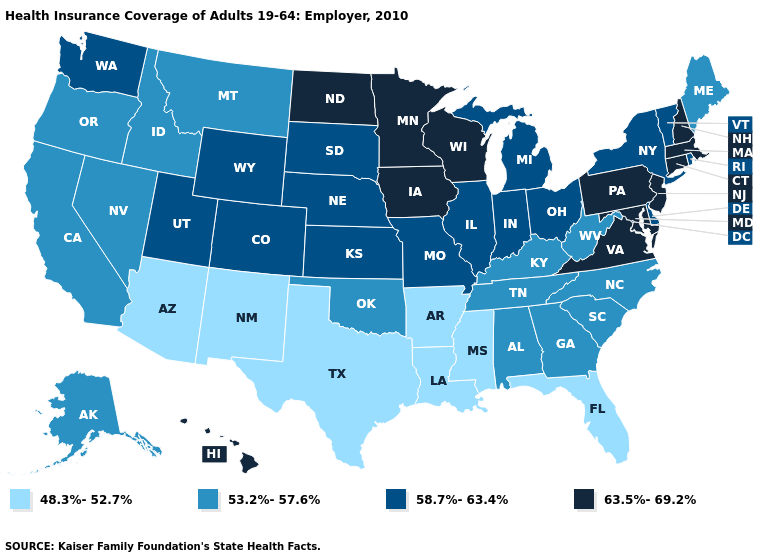What is the value of Louisiana?
Quick response, please. 48.3%-52.7%. Name the states that have a value in the range 63.5%-69.2%?
Answer briefly. Connecticut, Hawaii, Iowa, Maryland, Massachusetts, Minnesota, New Hampshire, New Jersey, North Dakota, Pennsylvania, Virginia, Wisconsin. Does Hawaii have the highest value in the West?
Quick response, please. Yes. What is the value of Kentucky?
Give a very brief answer. 53.2%-57.6%. What is the value of Vermont?
Be succinct. 58.7%-63.4%. What is the highest value in states that border West Virginia?
Short answer required. 63.5%-69.2%. Which states hav the highest value in the South?
Be succinct. Maryland, Virginia. What is the value of Wisconsin?
Answer briefly. 63.5%-69.2%. What is the value of Kansas?
Concise answer only. 58.7%-63.4%. Which states have the highest value in the USA?
Answer briefly. Connecticut, Hawaii, Iowa, Maryland, Massachusetts, Minnesota, New Hampshire, New Jersey, North Dakota, Pennsylvania, Virginia, Wisconsin. What is the value of Oregon?
Short answer required. 53.2%-57.6%. How many symbols are there in the legend?
Keep it brief. 4. Does Kansas have the highest value in the MidWest?
Keep it brief. No. What is the value of Oregon?
Give a very brief answer. 53.2%-57.6%. Does Maryland have the highest value in the USA?
Give a very brief answer. Yes. 